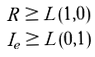<formula> <loc_0><loc_0><loc_500><loc_500>R & \geq L ( 1 , 0 ) \\ I _ { e } & \geq L ( 0 , 1 )</formula> 